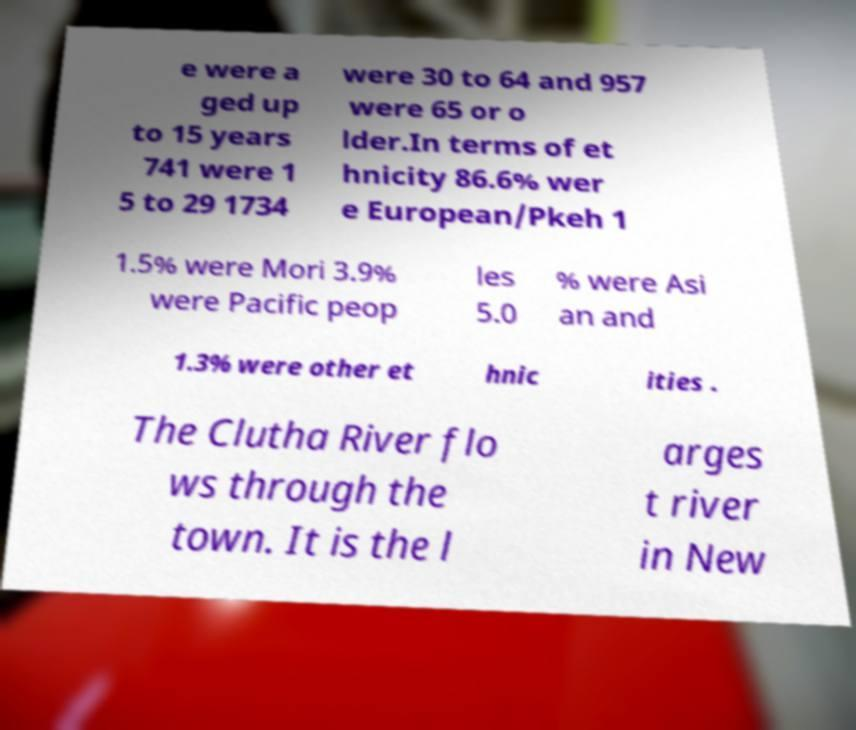For documentation purposes, I need the text within this image transcribed. Could you provide that? e were a ged up to 15 years 741 were 1 5 to 29 1734 were 30 to 64 and 957 were 65 or o lder.In terms of et hnicity 86.6% wer e European/Pkeh 1 1.5% were Mori 3.9% were Pacific peop les 5.0 % were Asi an and 1.3% were other et hnic ities . The Clutha River flo ws through the town. It is the l arges t river in New 